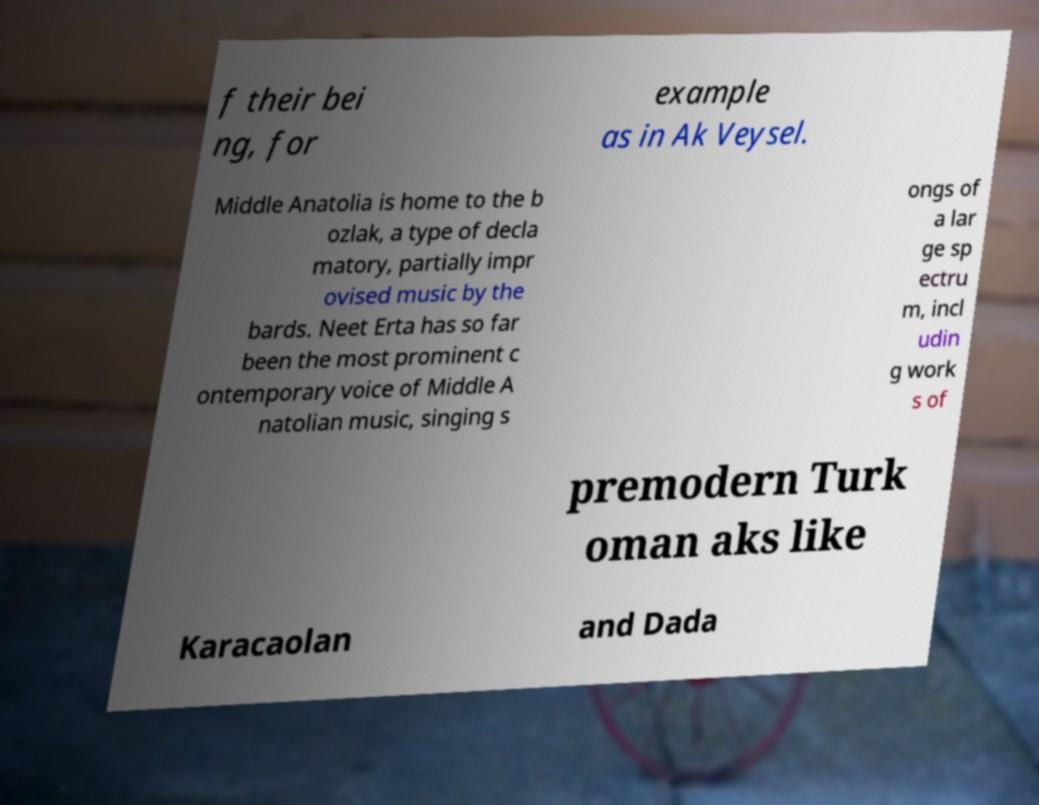Please identify and transcribe the text found in this image. f their bei ng, for example as in Ak Veysel. Middle Anatolia is home to the b ozlak, a type of decla matory, partially impr ovised music by the bards. Neet Erta has so far been the most prominent c ontemporary voice of Middle A natolian music, singing s ongs of a lar ge sp ectru m, incl udin g work s of premodern Turk oman aks like Karacaolan and Dada 